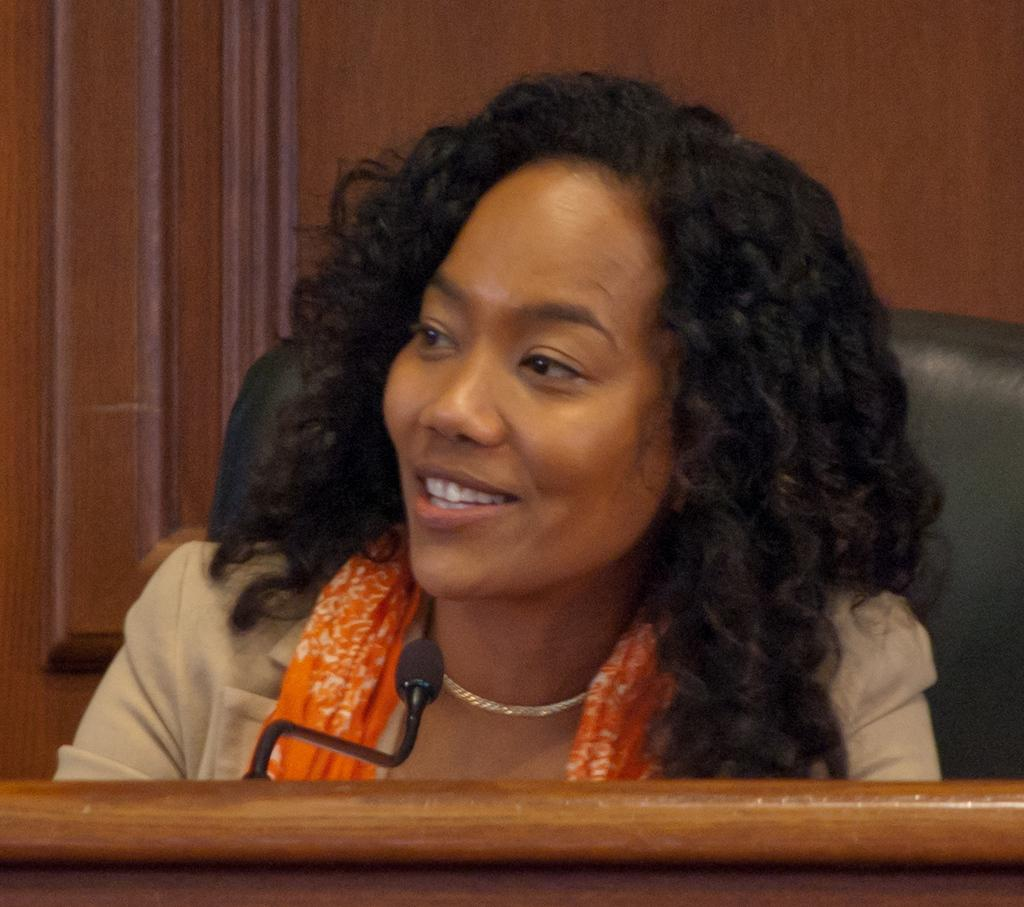Who is the main subject in the image? There is a woman in the image. What is the woman doing in the image? The woman is sitting in a chair. What object is in front of the woman? There is a podium in front of the woman. What is on the podium? A microphone is present on the podium. What can be seen in the background of the image? There is a wooden wall in the background of the image. What direction is the zephyr blowing in the image? There is no mention of a zephyr or wind in the image, so it cannot be determined which direction it might be blowing. 